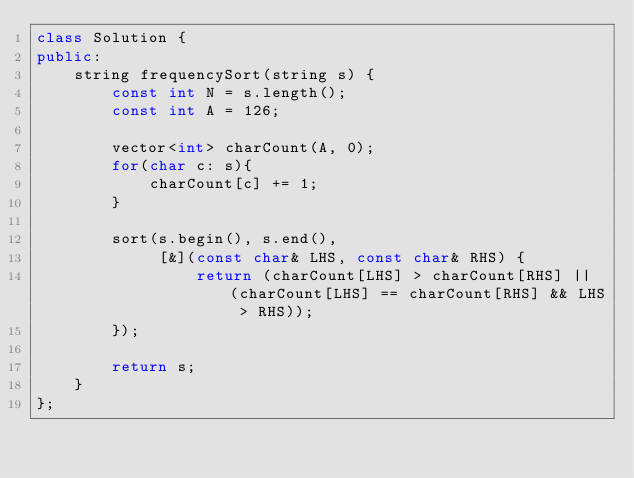<code> <loc_0><loc_0><loc_500><loc_500><_C++_>class Solution {
public:
    string frequencySort(string s) {
        const int N = s.length();
        const int A = 126;
        
        vector<int> charCount(A, 0);
        for(char c: s){
            charCount[c] += 1;
        }
        
        sort(s.begin(), s.end(),
             [&](const char& LHS, const char& RHS) {
                 return (charCount[LHS] > charCount[RHS] || (charCount[LHS] == charCount[RHS] && LHS > RHS));
        });
        
        return s;
    }
};</code> 